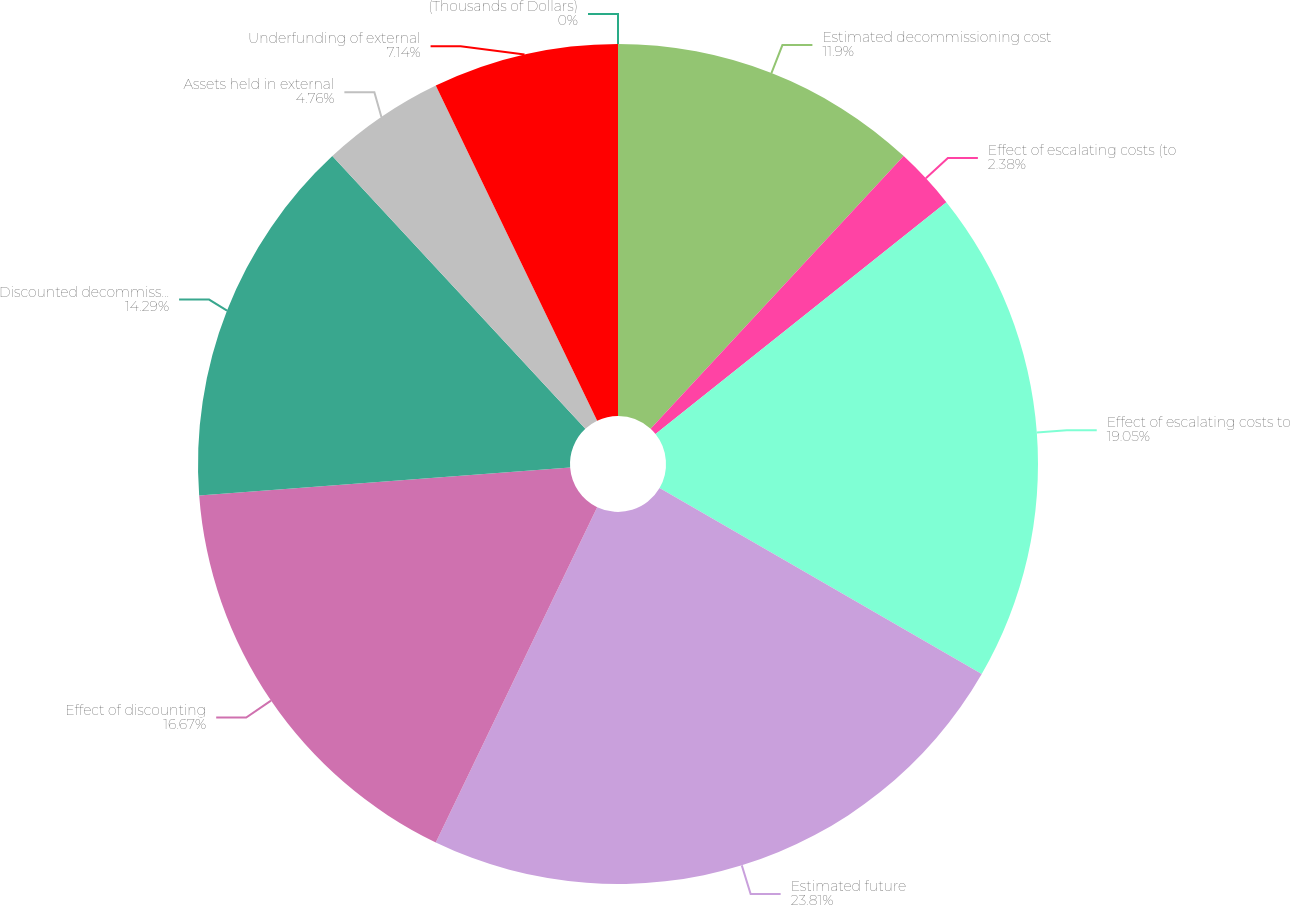Convert chart. <chart><loc_0><loc_0><loc_500><loc_500><pie_chart><fcel>(Thousands of Dollars)<fcel>Estimated decommissioning cost<fcel>Effect of escalating costs (to<fcel>Effect of escalating costs to<fcel>Estimated future<fcel>Effect of discounting<fcel>Discounted decommissioning<fcel>Assets held in external<fcel>Underfunding of external<nl><fcel>0.0%<fcel>11.9%<fcel>2.38%<fcel>19.04%<fcel>23.8%<fcel>16.66%<fcel>14.28%<fcel>4.76%<fcel>7.14%<nl></chart> 